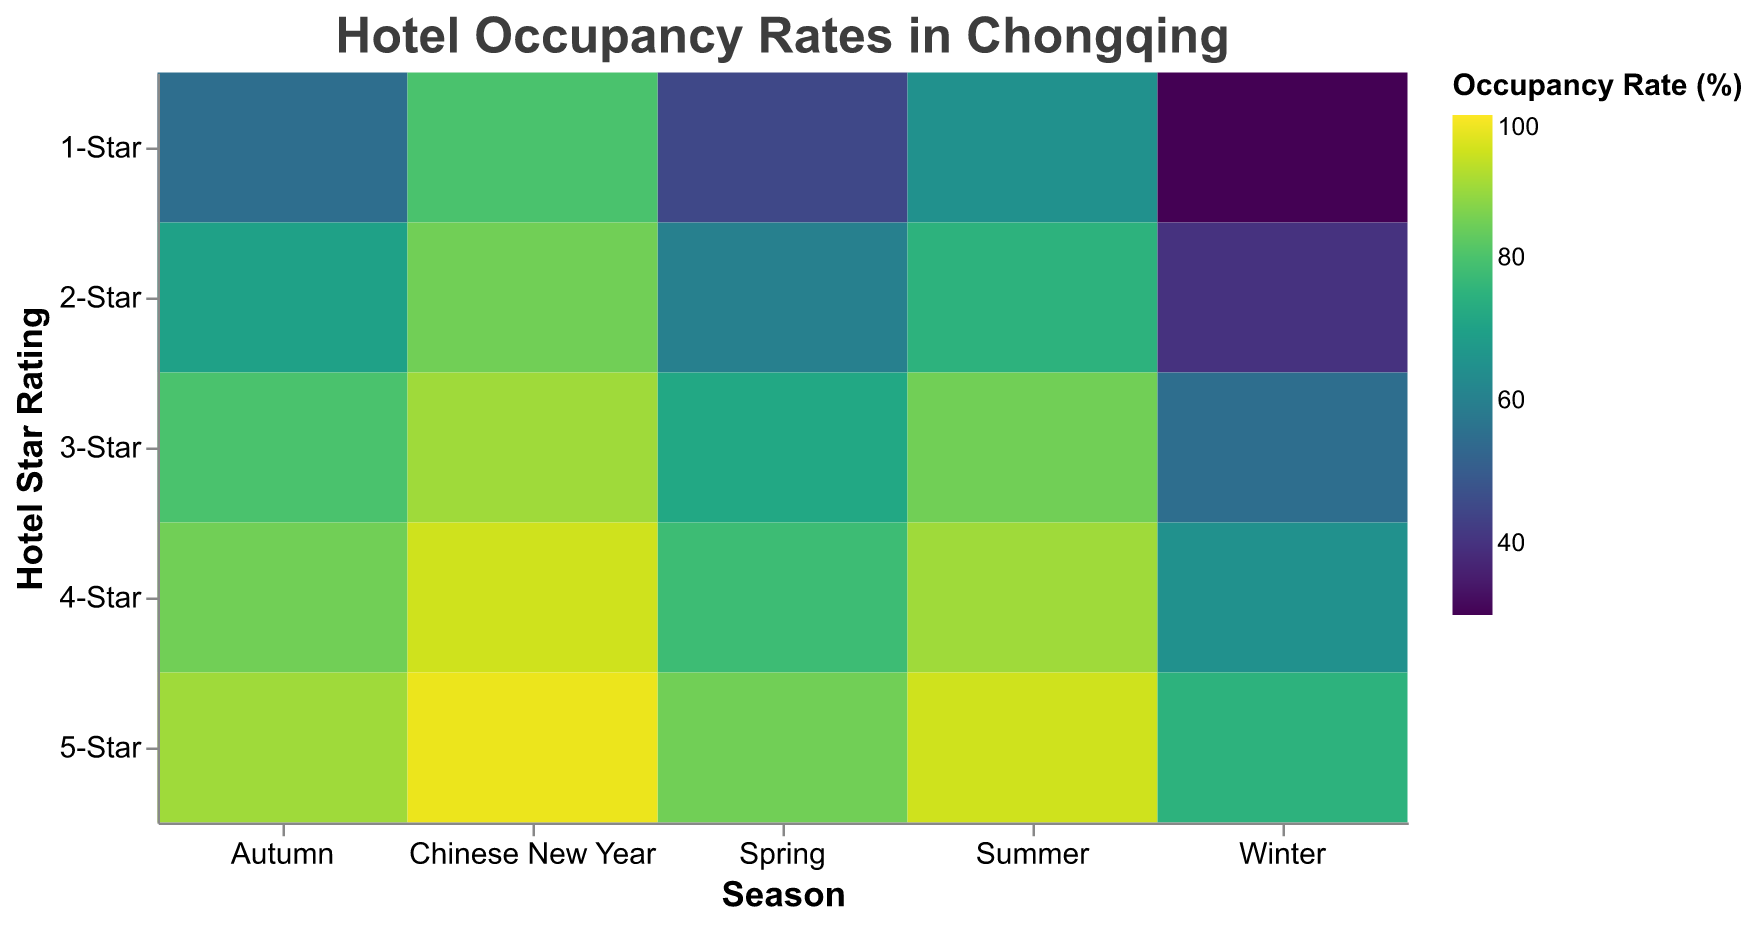What's the title of the plot? The title of the plot is displayed at the top of the visualization. It reads "Hotel Occupancy Rates in Chongqing."
Answer: Hotel Occupancy Rates in Chongqing Which season and star rating combination has the highest occupancy rate? To find the highest occupancy rate, look for the darkest color on the plot. The darkest color is found at the intersection of "Chinese New Year" and "5-Star," indicating the highest occupancy rate.
Answer: Chinese New Year and 5-Star What are the occupancy rates for 3-Star hotels during Summer and Winter? Locate the rows for Summer and Winter and find the corresponding occupancy rates for the 3-Star column. For Summer, it is 85%, and for Winter, it is 55%.
Answer: 85% and 55% Which season sees the lowest occupancy rate for 1-Star hotels? By examining the color shading in the "1-Star" row, the lightest shading represents the lowest occupancy rate. The lightest color appears in the Winter season.
Answer: Winter What is the average occupancy rate of 4-Star hotels over all seasons? To find the average, add the occupancy rates of 4-Star hotels for all seasons and divide by the number of seasons: (78 + 90 + 85 + 65 + 95) / 5. Thus, the calculation is (413 / 5).
Answer: 82.6% Which star rating category experiences the most significant range of occupancy rates across all seasons? The range is determined by subtracting the lowest occupancy rate from the highest within a star rating category. For 1-Star: 80-30 = 50, for 2-Star: 85-40 = 45, for 3-Star: 90-55 = 35, for 4-Star: 95-65 = 30, and for 5-Star: 98-75 = 23. The most significant range is for the 1-Star category.
Answer: 1-Star During Autumn, how does the occupancy rate for 3-Star hotels compare to 2-Star hotels? In the Autumn row, compare the vertical positions of 3-Star and 2-Star columns. The 3-Star hotel occupancy rate is 80%, and for 2-Star, it is 70%. 3-Star is higher by 10%.
Answer: 3-Star is higher Which season shows a consistent increase in occupancy rate from 1-Star to 5-Star hotels? To identify this, compare the occupancy rates from 1-Star to 5-Star within each season and find where each successive star rating has a higher occupancy rate consistently. During Chinese New Year, occupancy rates are 80, 85, 90, 95, and 98, a consistent increase.
Answer: Chinese New Year 